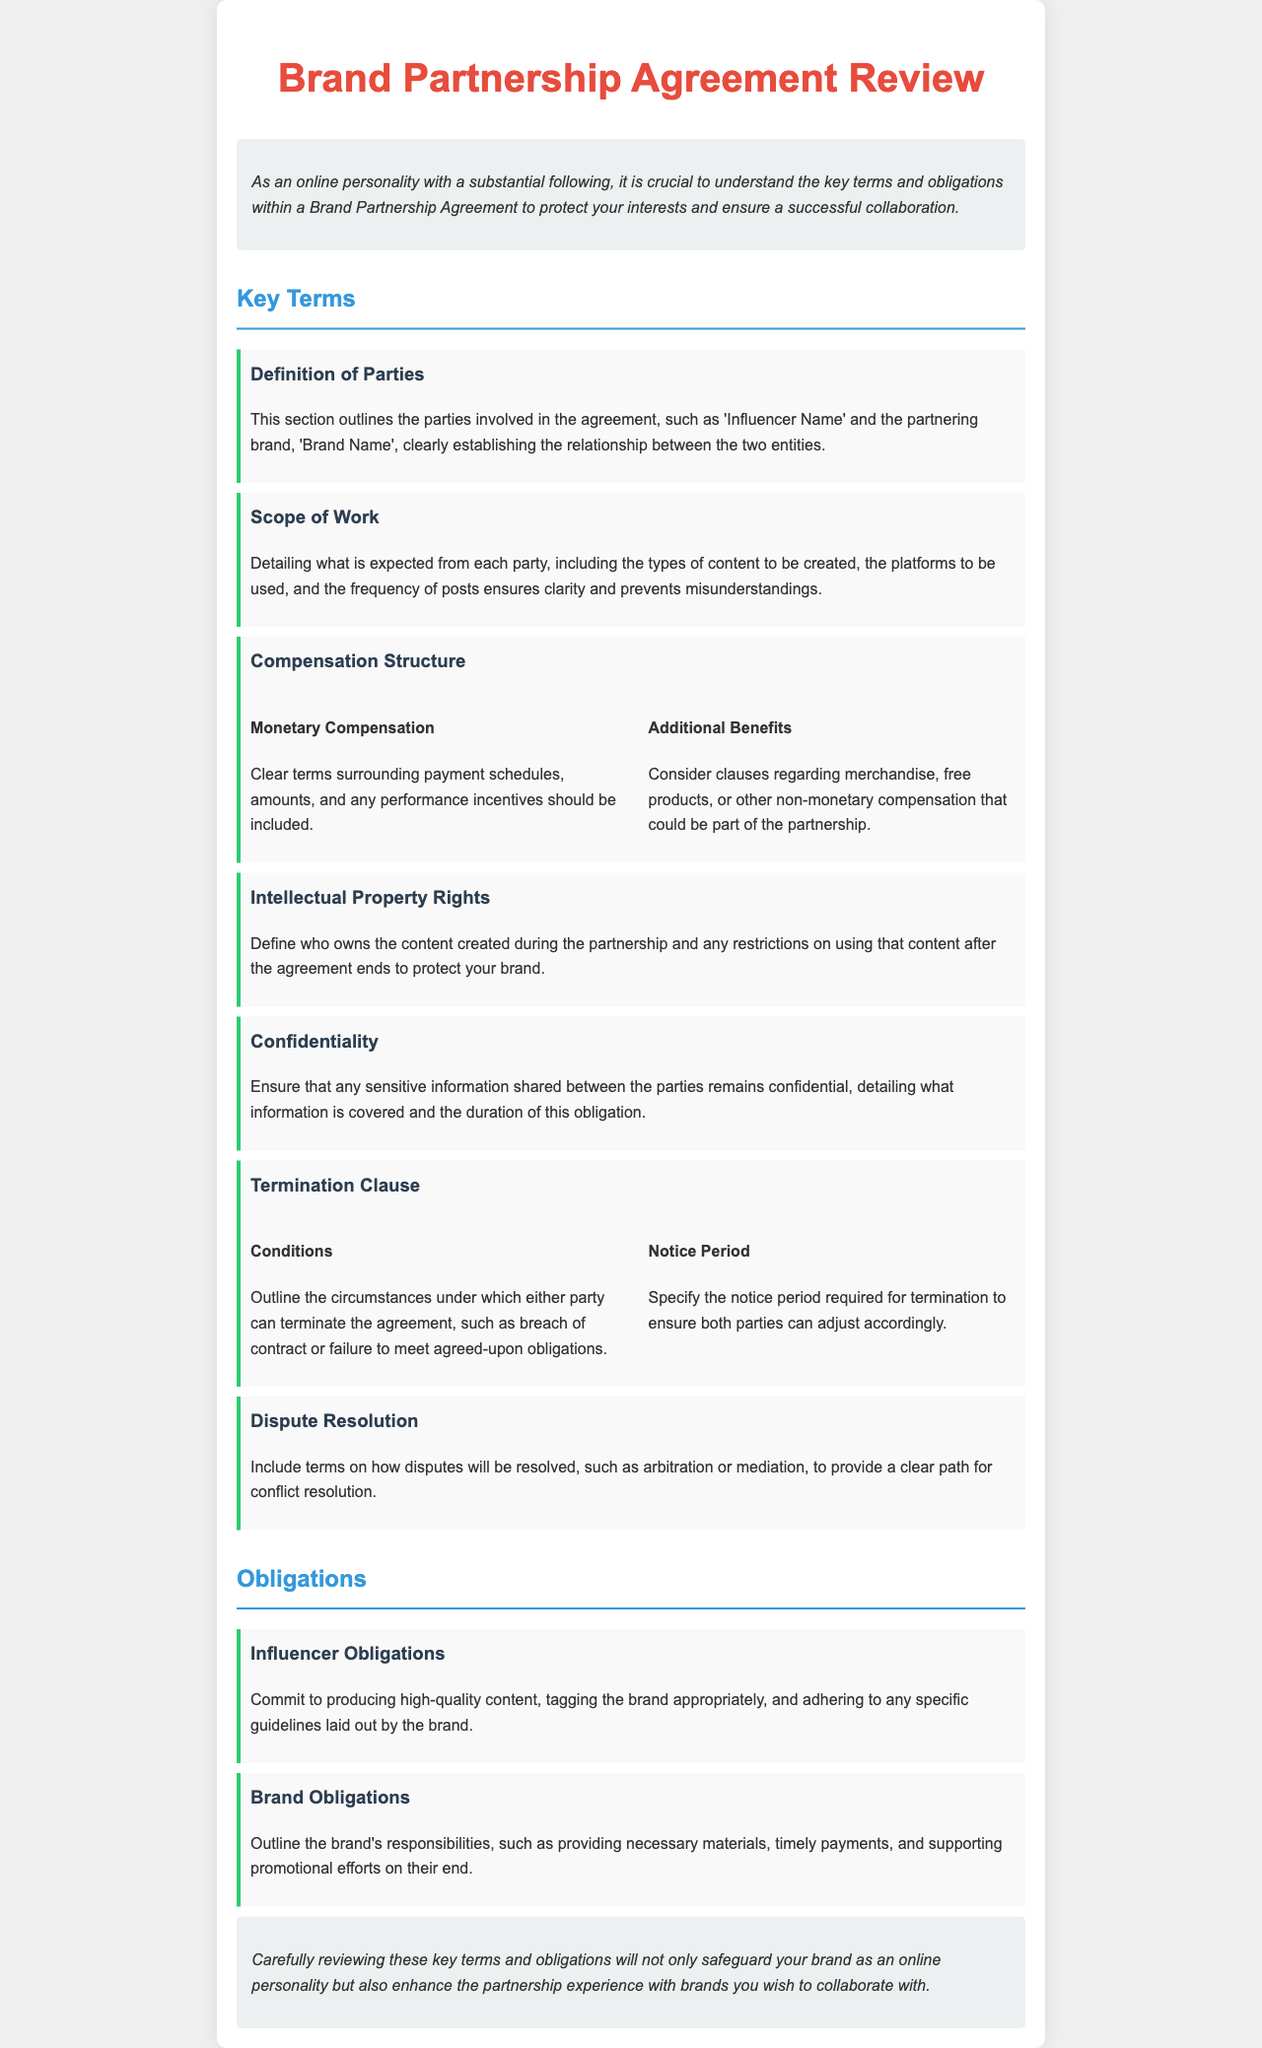What is the title of the document? The title is prominently displayed at the top of the document as the main heading.
Answer: Brand Partnership Agreement Review What color is used for the headings? This can be identified by looking at the font color for the various section titles in the document.
Answer: Red and blue What section details the obligations of the influencer? This information can be found within the "Obligations" section, indicating specific responsibilities for the influencer.
Answer: Influencer Obligations What is outlined in the "Scope of Work" section? The content discusses expectations regarding content creation and posting frequency, detailing responsibilities of each party.
Answer: Expectations for content types and posting What type of dispute resolution is mentioned? Referring to the "Dispute Resolution" section, this explains how conflicts will be addressed throughout the partnership.
Answer: Arbitration or mediation How many key terms are listed in total? By counting the number of distinct sections provided in the "Key Terms" section, one can determine the total.
Answer: Seven What is required in the notice period for termination? The document specifies the necessary notice period when discussing the termination conditions.
Answer: Notice period required for termination What is included in the compensation structure? The compensation details deal with both monetary and additional non-monetary compensation expected in the agreement.
Answer: Monetary and additional benefits What type of agreement does this document represent? By analyzing the introductory statement and general content of the document, its nature can be determined.
Answer: Partnership Agreement 